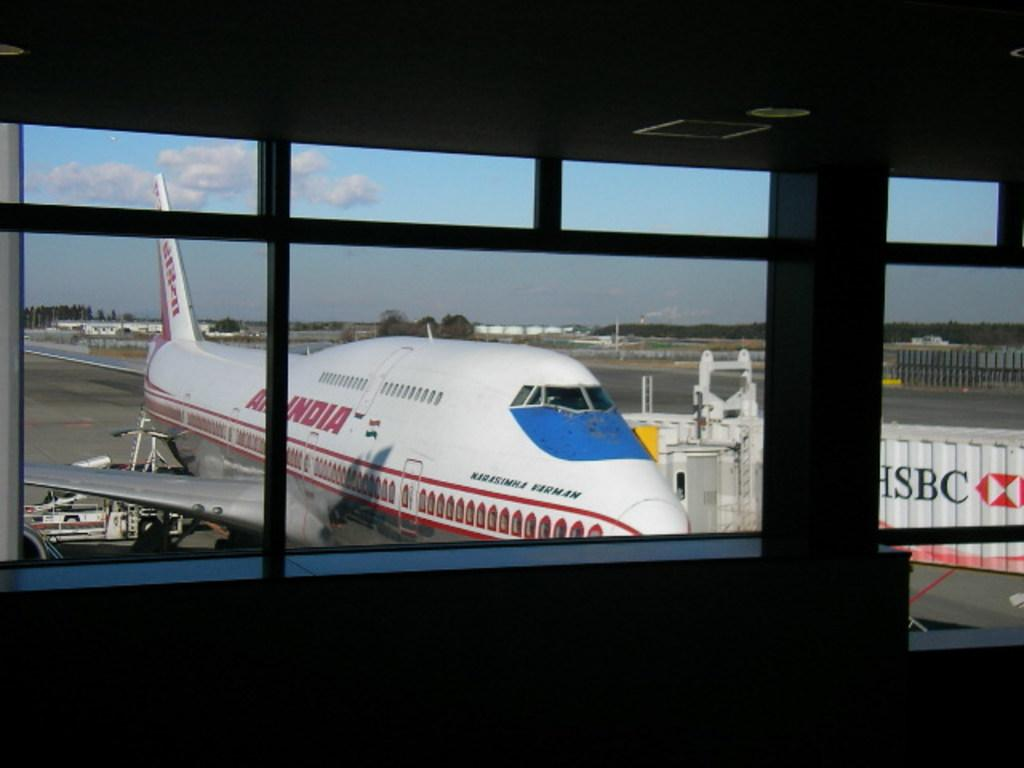<image>
Create a compact narrative representing the image presented. and HSBC container is sitting near an airplane 